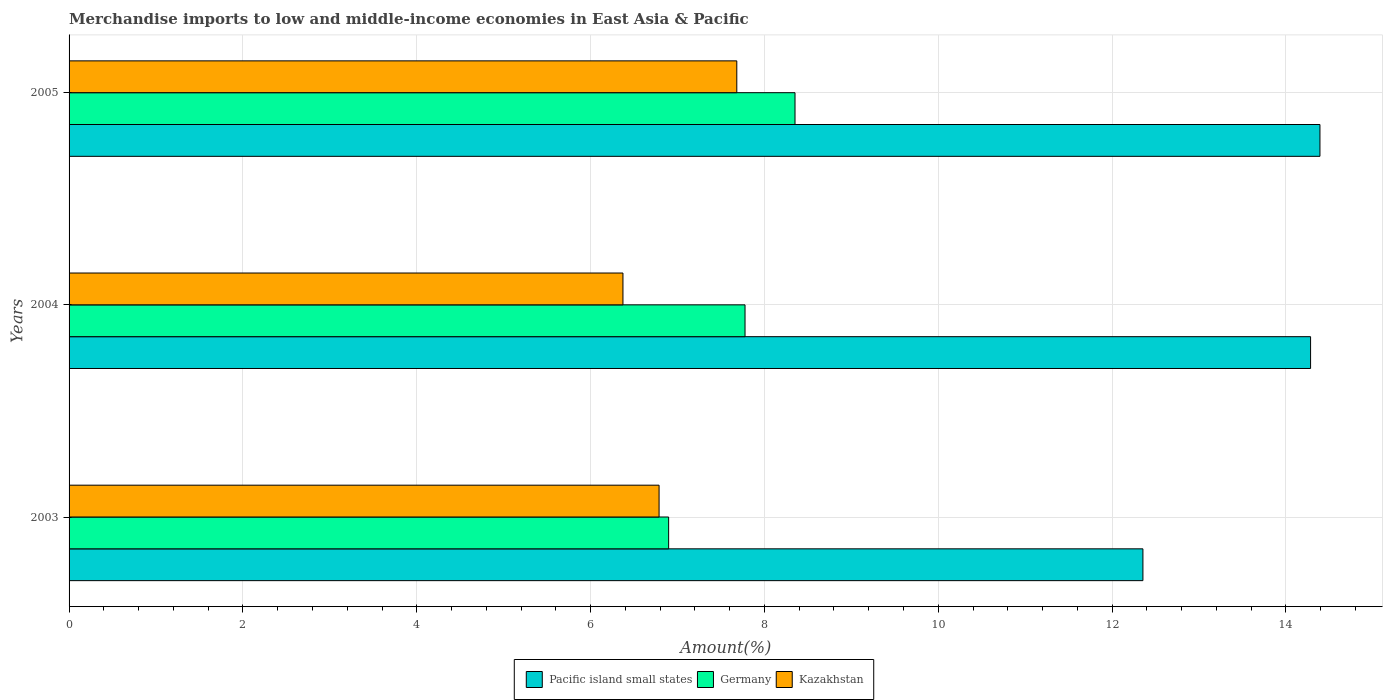How many groups of bars are there?
Your response must be concise. 3. Are the number of bars per tick equal to the number of legend labels?
Give a very brief answer. Yes. How many bars are there on the 2nd tick from the top?
Keep it short and to the point. 3. In how many cases, is the number of bars for a given year not equal to the number of legend labels?
Ensure brevity in your answer.  0. What is the percentage of amount earned from merchandise imports in Pacific island small states in 2003?
Ensure brevity in your answer.  12.35. Across all years, what is the maximum percentage of amount earned from merchandise imports in Kazakhstan?
Offer a terse response. 7.68. Across all years, what is the minimum percentage of amount earned from merchandise imports in Pacific island small states?
Keep it short and to the point. 12.35. In which year was the percentage of amount earned from merchandise imports in Pacific island small states maximum?
Your response must be concise. 2005. What is the total percentage of amount earned from merchandise imports in Kazakhstan in the graph?
Provide a succinct answer. 20.84. What is the difference between the percentage of amount earned from merchandise imports in Pacific island small states in 2004 and that in 2005?
Ensure brevity in your answer.  -0.11. What is the difference between the percentage of amount earned from merchandise imports in Pacific island small states in 2005 and the percentage of amount earned from merchandise imports in Germany in 2003?
Your response must be concise. 7.49. What is the average percentage of amount earned from merchandise imports in Pacific island small states per year?
Give a very brief answer. 13.68. In the year 2005, what is the difference between the percentage of amount earned from merchandise imports in Pacific island small states and percentage of amount earned from merchandise imports in Germany?
Offer a terse response. 6.04. In how many years, is the percentage of amount earned from merchandise imports in Kazakhstan greater than 4 %?
Provide a succinct answer. 3. What is the ratio of the percentage of amount earned from merchandise imports in Kazakhstan in 2004 to that in 2005?
Keep it short and to the point. 0.83. Is the difference between the percentage of amount earned from merchandise imports in Pacific island small states in 2003 and 2004 greater than the difference between the percentage of amount earned from merchandise imports in Germany in 2003 and 2004?
Your response must be concise. No. What is the difference between the highest and the second highest percentage of amount earned from merchandise imports in Pacific island small states?
Your answer should be very brief. 0.11. What is the difference between the highest and the lowest percentage of amount earned from merchandise imports in Kazakhstan?
Make the answer very short. 1.31. Is the sum of the percentage of amount earned from merchandise imports in Pacific island small states in 2004 and 2005 greater than the maximum percentage of amount earned from merchandise imports in Kazakhstan across all years?
Your answer should be compact. Yes. What does the 3rd bar from the top in 2004 represents?
Your answer should be very brief. Pacific island small states. What does the 3rd bar from the bottom in 2005 represents?
Provide a succinct answer. Kazakhstan. How many bars are there?
Provide a succinct answer. 9. Are all the bars in the graph horizontal?
Offer a very short reply. Yes. How many years are there in the graph?
Offer a very short reply. 3. What is the difference between two consecutive major ticks on the X-axis?
Keep it short and to the point. 2. Where does the legend appear in the graph?
Your answer should be very brief. Bottom center. What is the title of the graph?
Provide a succinct answer. Merchandise imports to low and middle-income economies in East Asia & Pacific. Does "Kyrgyz Republic" appear as one of the legend labels in the graph?
Your answer should be very brief. No. What is the label or title of the X-axis?
Offer a terse response. Amount(%). What is the Amount(%) of Pacific island small states in 2003?
Provide a succinct answer. 12.35. What is the Amount(%) in Germany in 2003?
Your response must be concise. 6.9. What is the Amount(%) in Kazakhstan in 2003?
Your answer should be compact. 6.79. What is the Amount(%) in Pacific island small states in 2004?
Give a very brief answer. 14.28. What is the Amount(%) in Germany in 2004?
Your answer should be very brief. 7.78. What is the Amount(%) of Kazakhstan in 2004?
Offer a terse response. 6.37. What is the Amount(%) of Pacific island small states in 2005?
Ensure brevity in your answer.  14.39. What is the Amount(%) of Germany in 2005?
Your answer should be compact. 8.35. What is the Amount(%) of Kazakhstan in 2005?
Ensure brevity in your answer.  7.68. Across all years, what is the maximum Amount(%) of Pacific island small states?
Make the answer very short. 14.39. Across all years, what is the maximum Amount(%) in Germany?
Give a very brief answer. 8.35. Across all years, what is the maximum Amount(%) in Kazakhstan?
Your response must be concise. 7.68. Across all years, what is the minimum Amount(%) of Pacific island small states?
Offer a terse response. 12.35. Across all years, what is the minimum Amount(%) of Germany?
Provide a succinct answer. 6.9. Across all years, what is the minimum Amount(%) of Kazakhstan?
Provide a short and direct response. 6.37. What is the total Amount(%) in Pacific island small states in the graph?
Your answer should be very brief. 41.03. What is the total Amount(%) of Germany in the graph?
Give a very brief answer. 23.03. What is the total Amount(%) in Kazakhstan in the graph?
Give a very brief answer. 20.84. What is the difference between the Amount(%) in Pacific island small states in 2003 and that in 2004?
Your response must be concise. -1.93. What is the difference between the Amount(%) of Germany in 2003 and that in 2004?
Keep it short and to the point. -0.88. What is the difference between the Amount(%) of Kazakhstan in 2003 and that in 2004?
Your response must be concise. 0.42. What is the difference between the Amount(%) of Pacific island small states in 2003 and that in 2005?
Ensure brevity in your answer.  -2.04. What is the difference between the Amount(%) of Germany in 2003 and that in 2005?
Keep it short and to the point. -1.45. What is the difference between the Amount(%) in Kazakhstan in 2003 and that in 2005?
Provide a succinct answer. -0.89. What is the difference between the Amount(%) of Pacific island small states in 2004 and that in 2005?
Offer a terse response. -0.11. What is the difference between the Amount(%) of Germany in 2004 and that in 2005?
Your answer should be compact. -0.57. What is the difference between the Amount(%) of Kazakhstan in 2004 and that in 2005?
Make the answer very short. -1.31. What is the difference between the Amount(%) in Pacific island small states in 2003 and the Amount(%) in Germany in 2004?
Your answer should be very brief. 4.58. What is the difference between the Amount(%) of Pacific island small states in 2003 and the Amount(%) of Kazakhstan in 2004?
Offer a very short reply. 5.98. What is the difference between the Amount(%) in Germany in 2003 and the Amount(%) in Kazakhstan in 2004?
Offer a very short reply. 0.53. What is the difference between the Amount(%) of Pacific island small states in 2003 and the Amount(%) of Germany in 2005?
Provide a succinct answer. 4. What is the difference between the Amount(%) in Pacific island small states in 2003 and the Amount(%) in Kazakhstan in 2005?
Your response must be concise. 4.67. What is the difference between the Amount(%) in Germany in 2003 and the Amount(%) in Kazakhstan in 2005?
Provide a short and direct response. -0.78. What is the difference between the Amount(%) in Pacific island small states in 2004 and the Amount(%) in Germany in 2005?
Offer a terse response. 5.93. What is the difference between the Amount(%) in Pacific island small states in 2004 and the Amount(%) in Kazakhstan in 2005?
Offer a terse response. 6.6. What is the difference between the Amount(%) of Germany in 2004 and the Amount(%) of Kazakhstan in 2005?
Offer a terse response. 0.09. What is the average Amount(%) of Pacific island small states per year?
Make the answer very short. 13.68. What is the average Amount(%) of Germany per year?
Offer a terse response. 7.68. What is the average Amount(%) in Kazakhstan per year?
Keep it short and to the point. 6.95. In the year 2003, what is the difference between the Amount(%) in Pacific island small states and Amount(%) in Germany?
Offer a very short reply. 5.46. In the year 2003, what is the difference between the Amount(%) in Pacific island small states and Amount(%) in Kazakhstan?
Offer a very short reply. 5.57. In the year 2003, what is the difference between the Amount(%) in Germany and Amount(%) in Kazakhstan?
Give a very brief answer. 0.11. In the year 2004, what is the difference between the Amount(%) of Pacific island small states and Amount(%) of Germany?
Your answer should be very brief. 6.51. In the year 2004, what is the difference between the Amount(%) in Pacific island small states and Amount(%) in Kazakhstan?
Keep it short and to the point. 7.91. In the year 2004, what is the difference between the Amount(%) of Germany and Amount(%) of Kazakhstan?
Offer a very short reply. 1.4. In the year 2005, what is the difference between the Amount(%) of Pacific island small states and Amount(%) of Germany?
Ensure brevity in your answer.  6.04. In the year 2005, what is the difference between the Amount(%) in Pacific island small states and Amount(%) in Kazakhstan?
Your answer should be very brief. 6.71. In the year 2005, what is the difference between the Amount(%) of Germany and Amount(%) of Kazakhstan?
Your answer should be compact. 0.67. What is the ratio of the Amount(%) of Pacific island small states in 2003 to that in 2004?
Give a very brief answer. 0.86. What is the ratio of the Amount(%) of Germany in 2003 to that in 2004?
Offer a very short reply. 0.89. What is the ratio of the Amount(%) in Kazakhstan in 2003 to that in 2004?
Your response must be concise. 1.07. What is the ratio of the Amount(%) of Pacific island small states in 2003 to that in 2005?
Keep it short and to the point. 0.86. What is the ratio of the Amount(%) of Germany in 2003 to that in 2005?
Offer a terse response. 0.83. What is the ratio of the Amount(%) of Kazakhstan in 2003 to that in 2005?
Offer a terse response. 0.88. What is the ratio of the Amount(%) of Germany in 2004 to that in 2005?
Ensure brevity in your answer.  0.93. What is the ratio of the Amount(%) in Kazakhstan in 2004 to that in 2005?
Your response must be concise. 0.83. What is the difference between the highest and the second highest Amount(%) in Pacific island small states?
Keep it short and to the point. 0.11. What is the difference between the highest and the second highest Amount(%) of Germany?
Make the answer very short. 0.57. What is the difference between the highest and the second highest Amount(%) in Kazakhstan?
Your response must be concise. 0.89. What is the difference between the highest and the lowest Amount(%) in Pacific island small states?
Make the answer very short. 2.04. What is the difference between the highest and the lowest Amount(%) of Germany?
Make the answer very short. 1.45. What is the difference between the highest and the lowest Amount(%) of Kazakhstan?
Offer a very short reply. 1.31. 